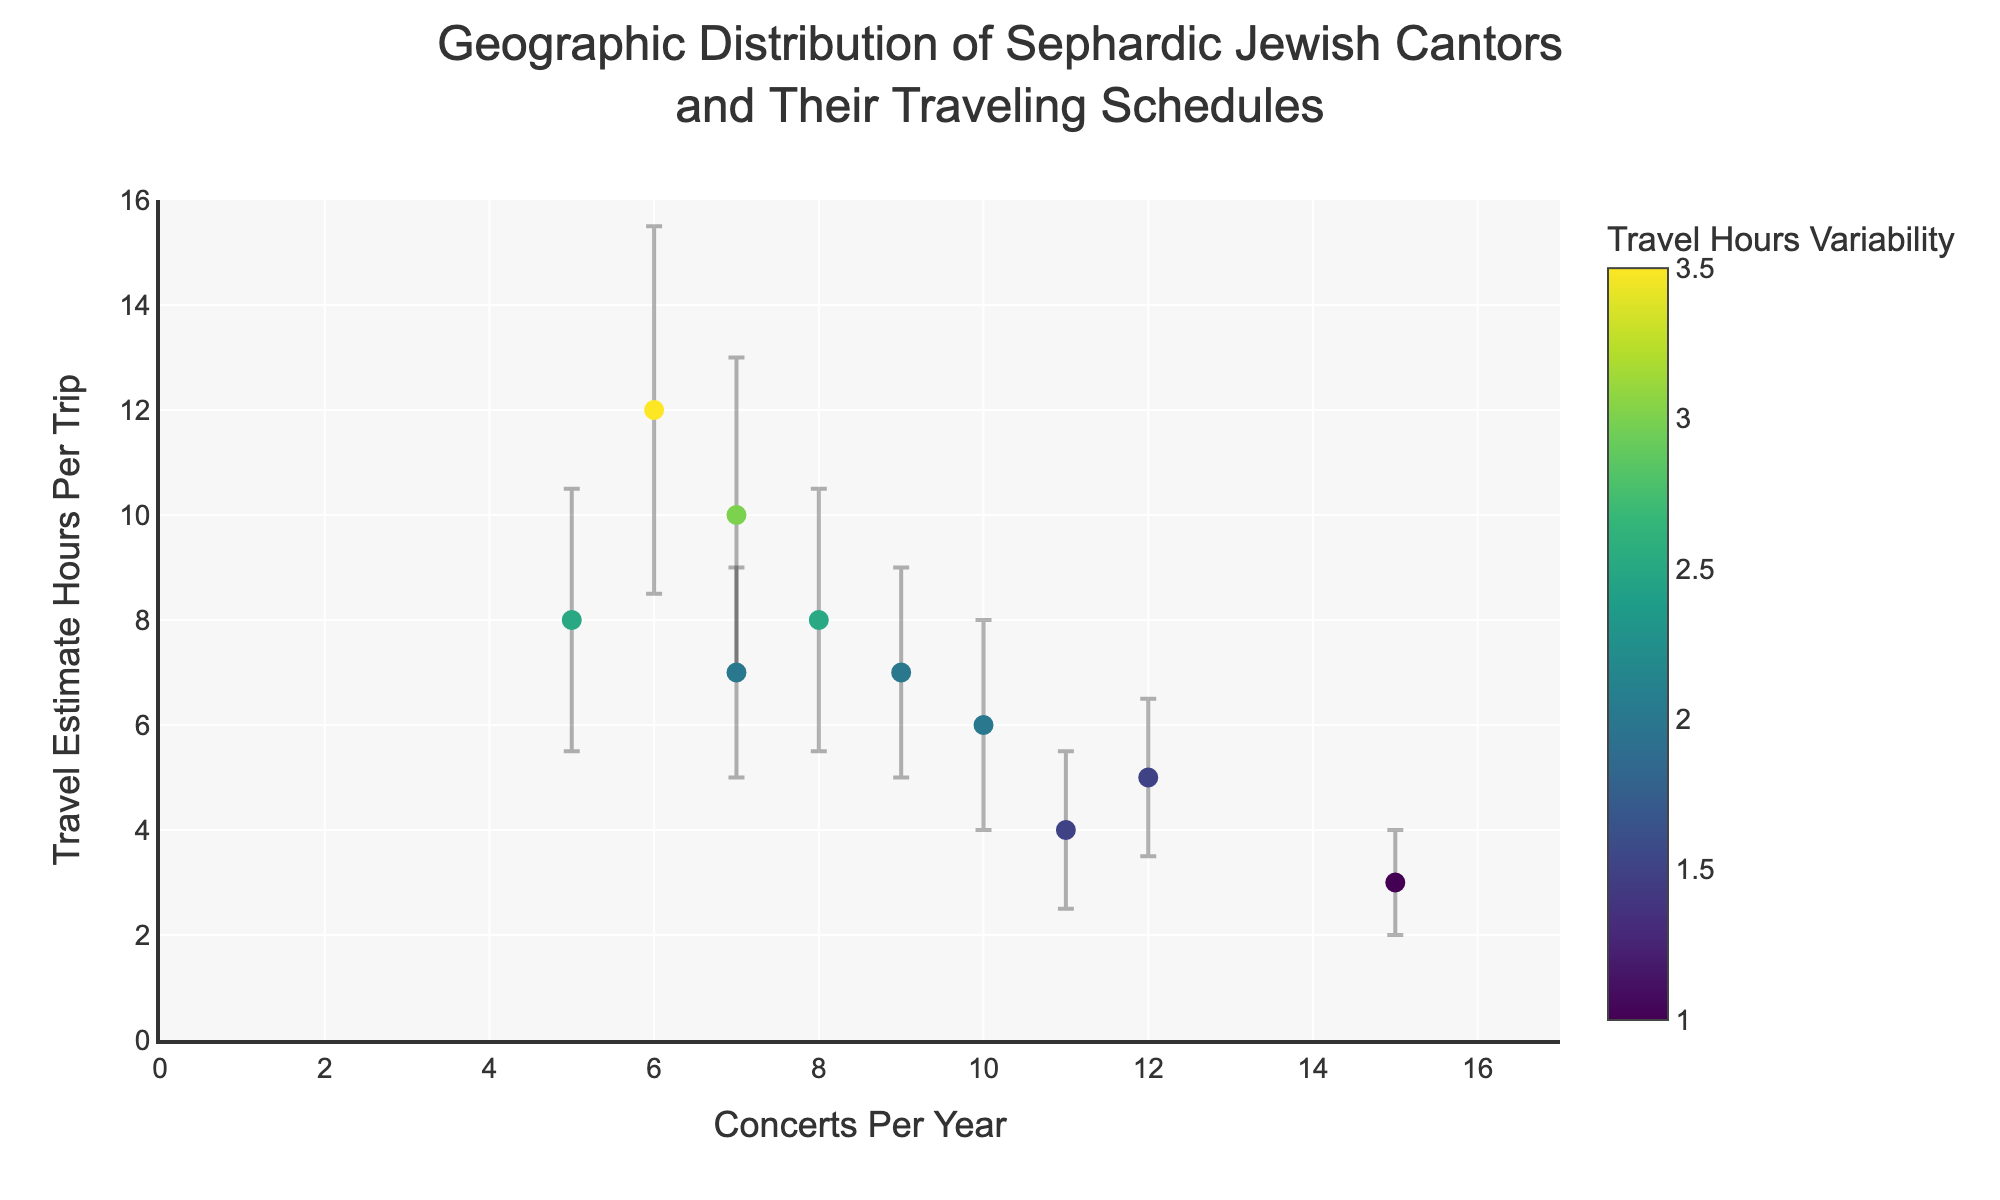How many cantors are represented in the figure? Count the number of unique data points in the scatter plot. Each point corresponds to a cantor.
Answer: 10 What is the title of the figure? Look at the top of the figure to find the main heading or title that describes what the plot represents.
Answer: Geographic Distribution of Sephardic Jewish Cantors and Their Traveling Schedules Which cantor has the highest number of concerts per year? Identify the data point furthest to the right on the x-axis (Concerts Per Year). Hover over this point to see the cantor's name.
Answer: David Azoulay What is the average travel estimate hours per trip among all the cantors? Sum the travel estimate hours per trip for each cantor and divide by the number of cantors. Calculation: (5 + 6 + 3 + 8 + 7 + 10 + 12 + 4 + 8 + 7) / 10 = 70 / 10
Answer: 7 Which cantor has the greatest variability in travel hours? Look for the data point with the largest error bars (vertical lines) indicating the variability measure. Hover over this point to see the cantor's name.
Answer: Isaac Toledano How many concerts per year does Sarah Benamou perform? Locate Sarah Benamou's data point by hovering over the points until her name appears. Then, check the x-axis value for this point.
Answer: 8 Which cantor travels the least (in hours per trip) on average? Identify the data point closest to the bottom on the y-axis (Travel Estimate Hours Per Trip). Hover over this point to see the cantor's name.
Answer: David Azoulay What are the travel estimate hours per trip and variability for Rebecca Mizrahi? Find Rebecca Mizrahi's data point by hovering over the points until her name appears. Note the y-axis value and the height of the error bars.
Answer: 4 hours, 1.5 variability Who has more variability in travel hours, Rachel Cohen or Moses Levy? Compare the heights of the error bars for Rachel Cohen and Moses Levy by looking at their data points.
Answer: Rachel Cohen What is the relationship between the number of concerts per year and the travel estimate hours per trip? Observe the general trend of the scatter plot to describe how changes in concerts per year relate to changes in travel estimate hours per trip. This requires analyzing the distribution of data points across the plot.
Answer: No clear trend visible 